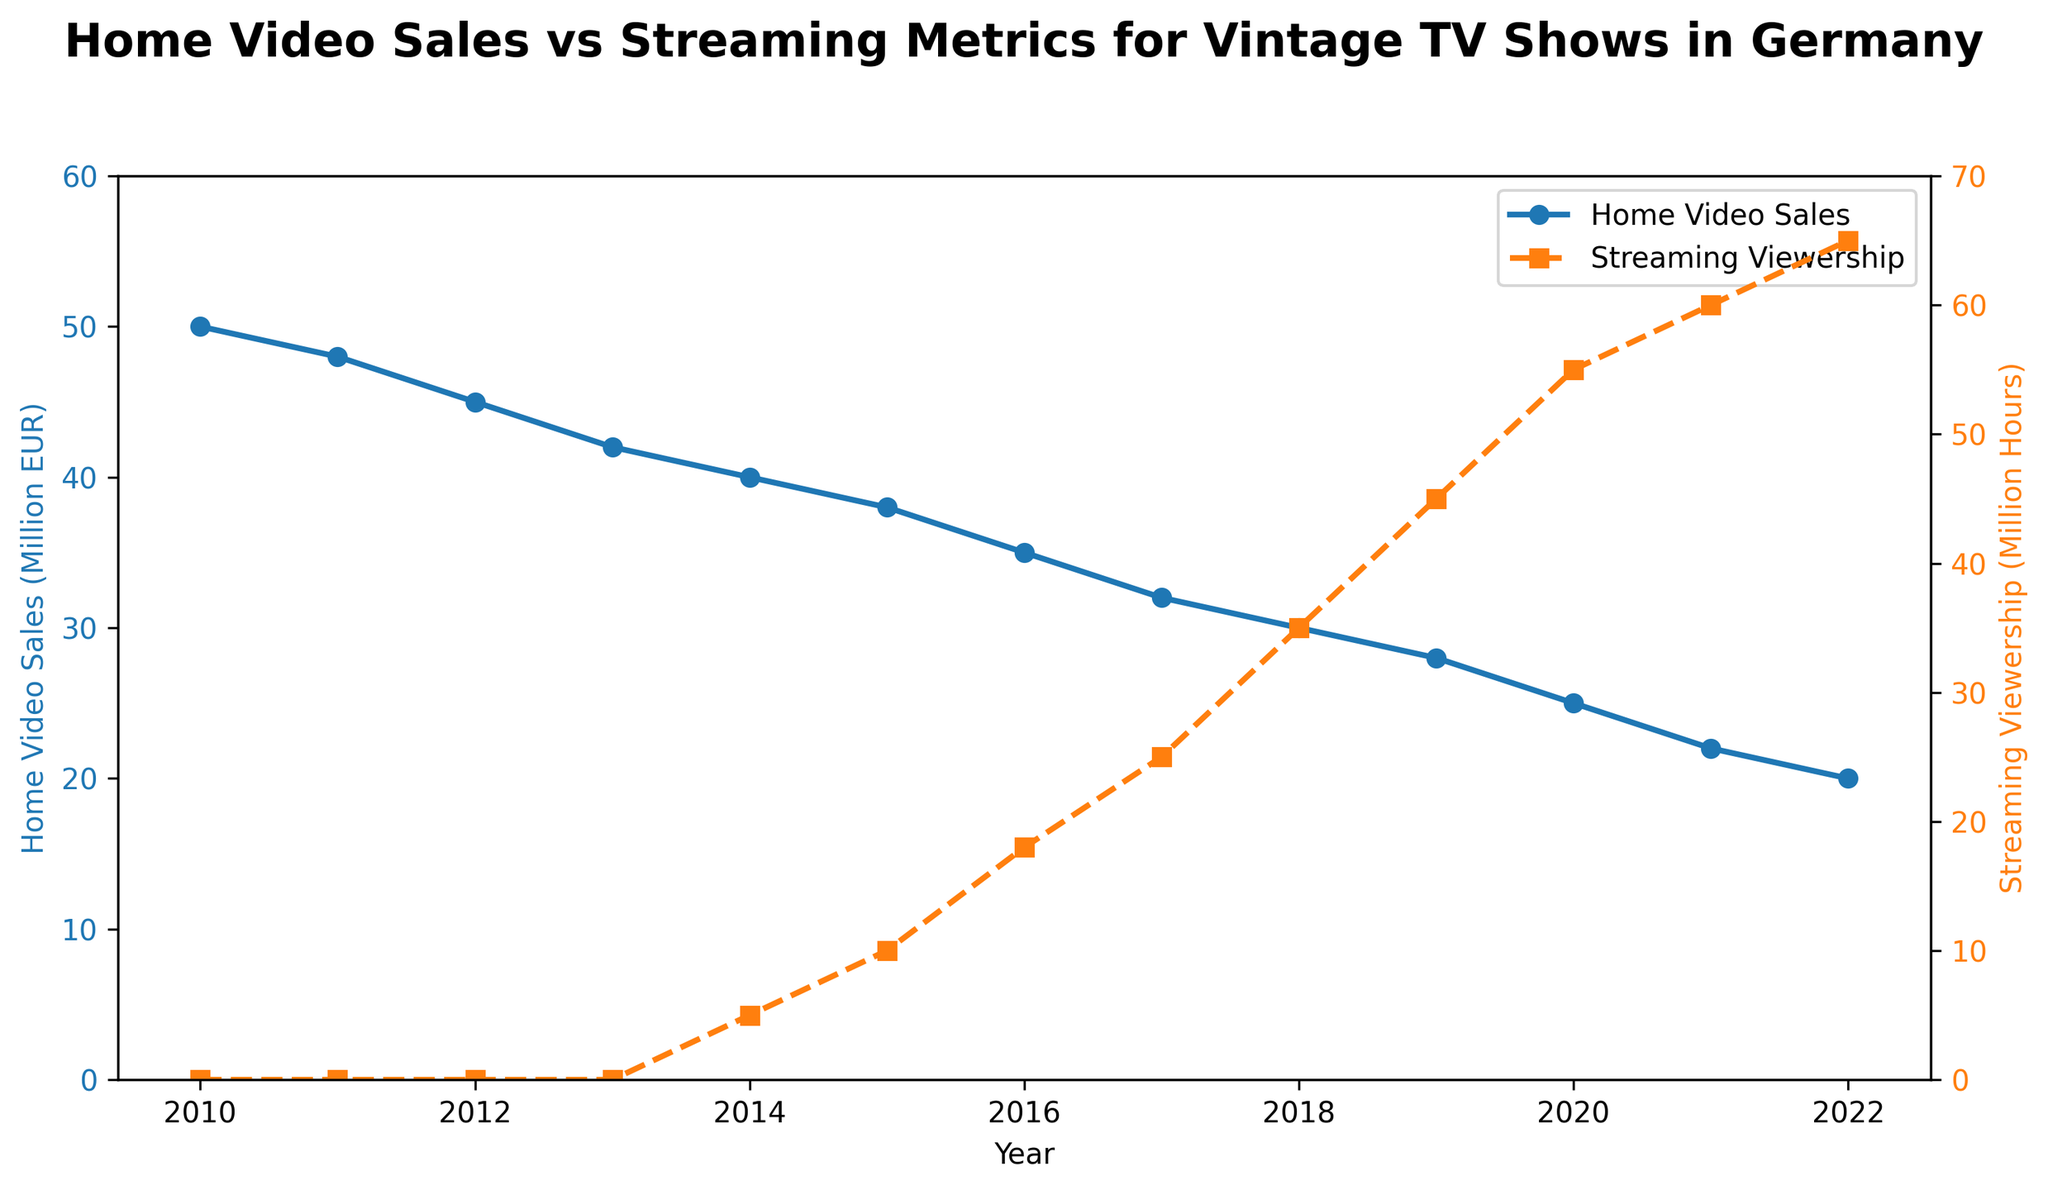What was the Home Video Sales figure for the year 2014? Look at the line pertaining to Home Video Sales in 2014, where the blue line intersects with the vertical line at 2014 on the x-axis.
Answer: 40 million EUR Which year saw the highest Streaming Viewership? Look at the orange dashed line to find the highest point on the y-axis. This occurs at the intersection with the vertical line corresponding to the year.
Answer: 2022 How many million hours was the Streaming Viewership in 2020? Observe the orange dashed line at the point where 2020 is located on the x-axis.
Answer: 55 million hours What is the difference between Home Video Sales and Streaming Viewership in 2016? Note the Home Video Sales (35 million EUR) and Streaming Viewership (18 million hours) for 2016, then compute the difference: 35 - 18.
Answer: 17 How has the trend of Home Video Sales and Streaming Viewership changed from 2010 to 2022? Observe the downward slope of the blue line (Home Video Sales) and the upward slope of the orange dashed line (Streaming Viewership) from 2010 to 2022.
Answer: Home Video Sales decreased, Streaming Viewership increased Compare the Home Video Sales and Streaming Viewership in 2015. Which was higher? Look at the values for both metrics in 2015. Home Video Sales was 38 million EUR, and Streaming Viewership was 10 million hours, so Home Video Sales was higher.
Answer: Home Video Sales Calculate the average Streaming Viewership from 2014 to 2022. Sum the Streaming Viewership from 2014 to 2022 (5+10+18+25+35+45+55+60+65 = 318) and divide by 9 (number of years).
Answer: 35.33 million hours In which year did Streaming Viewership surpass 30 million hours? Find the first year where the orange dashed line reaches above the 30 million mark on the y-axis.
Answer: 2018 Which metric showed a faster increase after its initial rise, Home Video Sales or Streaming Viewership? Reference the steepness of both lines from their origin points of increase. Streaming Viewership increases more steeply after 2014 compared to Home Video Sales.
Answer: Streaming Viewership 